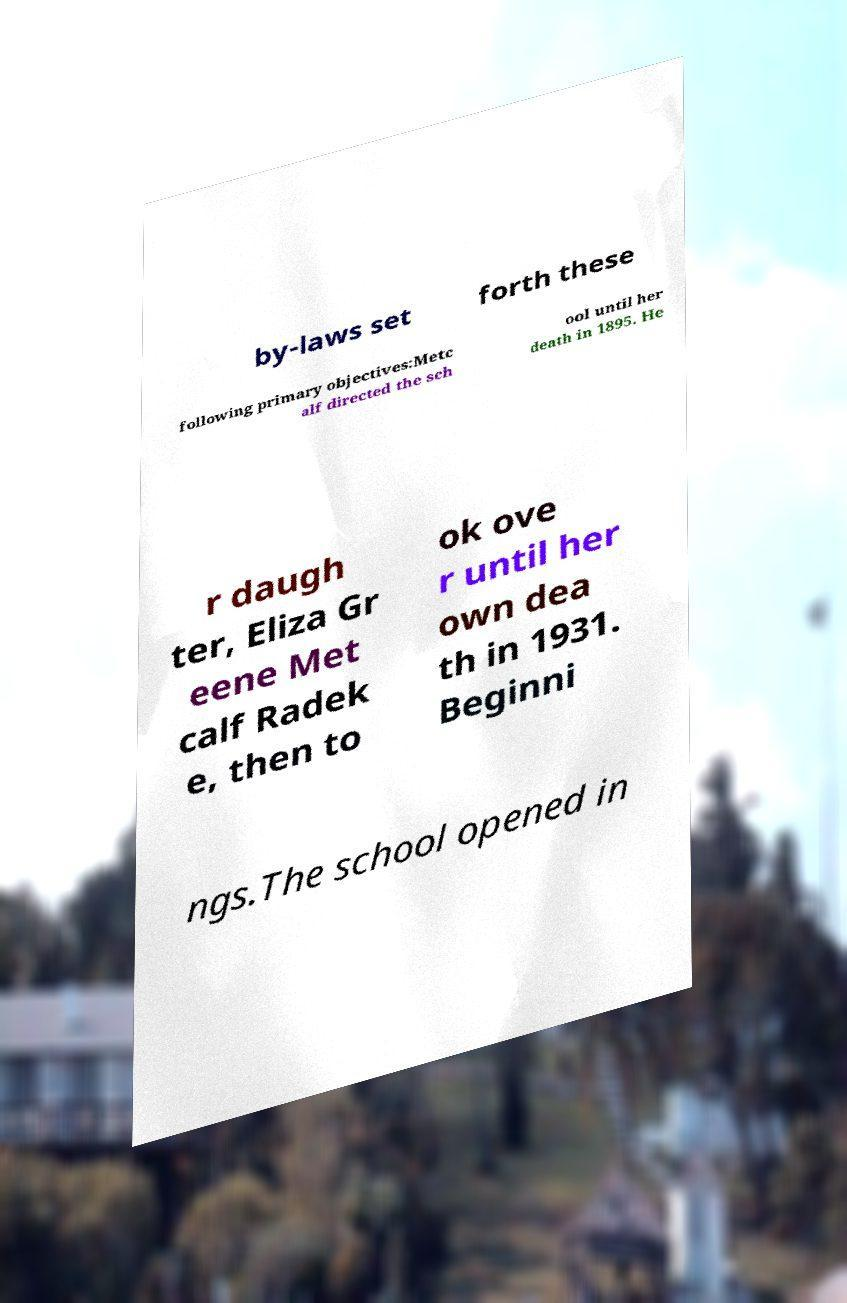Could you extract and type out the text from this image? by-laws set forth these following primary objectives:Metc alf directed the sch ool until her death in 1895. He r daugh ter, Eliza Gr eene Met calf Radek e, then to ok ove r until her own dea th in 1931. Beginni ngs.The school opened in 